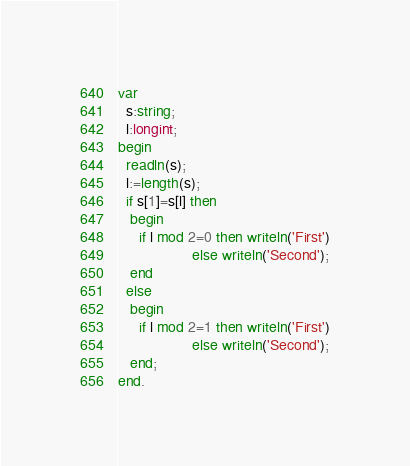<code> <loc_0><loc_0><loc_500><loc_500><_Pascal_>var
  s:string;
  l:longint;
begin
  readln(s);
  l:=length(s);
  if s[1]=s[l] then
   begin
     if l mod 2=0 then writeln('First')
                  else writeln('Second');
   end
  else
   begin
     if l mod 2=1 then writeln('First')
                  else writeln('Second');
   end;
end.</code> 